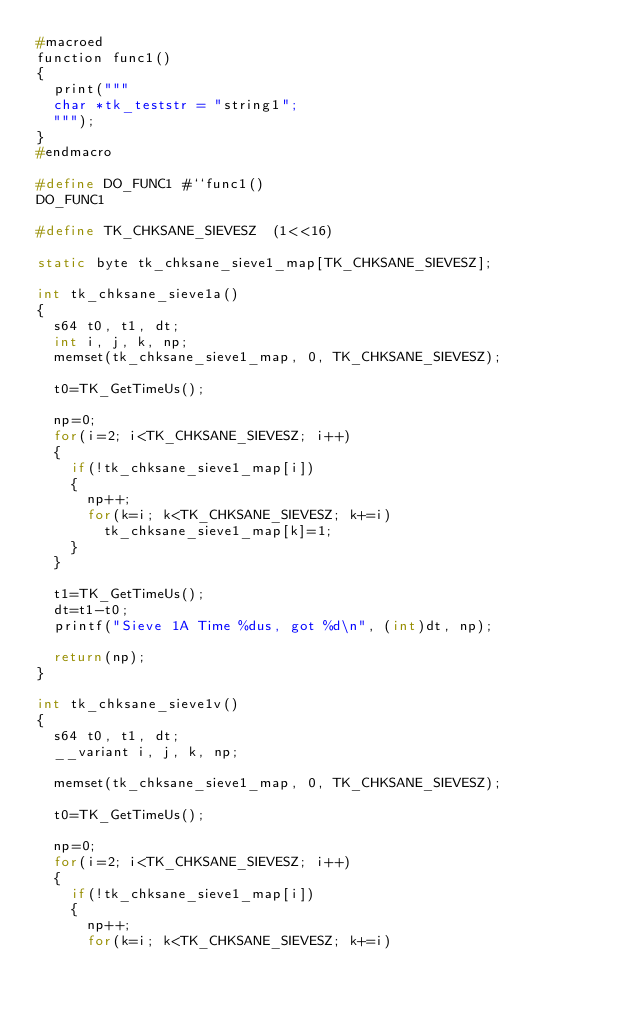Convert code to text. <code><loc_0><loc_0><loc_500><loc_500><_C_>#macroed
function func1()
{
	print("""
	char *tk_teststr = "string1";
	""");
}
#endmacro

#define DO_FUNC1 #``func1()
DO_FUNC1

#define TK_CHKSANE_SIEVESZ	(1<<16)

static byte tk_chksane_sieve1_map[TK_CHKSANE_SIEVESZ];

int tk_chksane_sieve1a()
{
	s64 t0, t1, dt;
	int i, j, k, np;
	memset(tk_chksane_sieve1_map, 0, TK_CHKSANE_SIEVESZ);
	
	t0=TK_GetTimeUs();
	
	np=0;
	for(i=2; i<TK_CHKSANE_SIEVESZ; i++)
	{
		if(!tk_chksane_sieve1_map[i])
		{
			np++;
			for(k=i; k<TK_CHKSANE_SIEVESZ; k+=i)
				tk_chksane_sieve1_map[k]=1;
		}
	}

	t1=TK_GetTimeUs();
	dt=t1-t0;
	printf("Sieve 1A Time %dus, got %d\n", (int)dt, np);

	return(np);
}

int tk_chksane_sieve1v()
{
	s64 t0, t1, dt;
	__variant i, j, k, np;

	memset(tk_chksane_sieve1_map, 0, TK_CHKSANE_SIEVESZ);
	
	t0=TK_GetTimeUs();
	
	np=0;
	for(i=2; i<TK_CHKSANE_SIEVESZ; i++)
	{
		if(!tk_chksane_sieve1_map[i])
		{
			np++;
			for(k=i; k<TK_CHKSANE_SIEVESZ; k+=i)</code> 